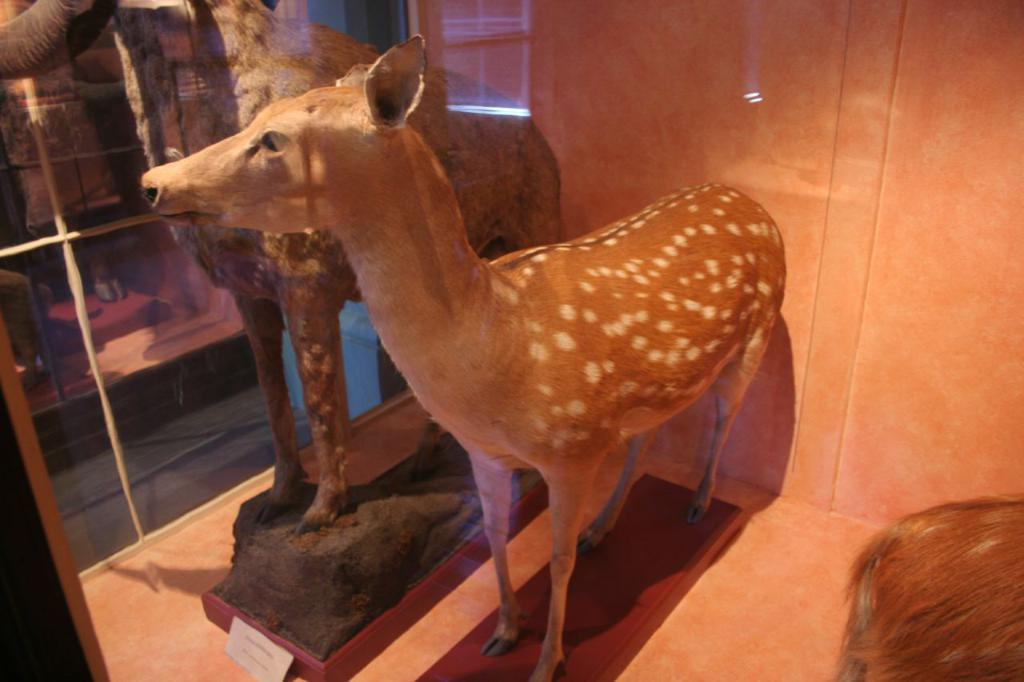What object is present in the image that can hold a liquid? There is a glass in the image. What can be seen through the glass? Animal sculptures are visible through the glass. What is located behind the animal sculptures? There is a wall behind the sculptures. What type of birds can be seen swimming in the ocean in the image? There are no birds or ocean present in the image; it features a glass with animal sculptures and a wall behind them. 